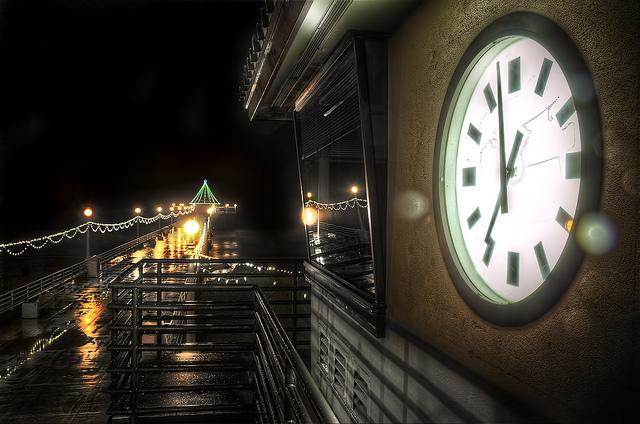Is it late in the day?
Concise answer only. Yes. What time is it?
Keep it brief. 7:00. Does it look like it is raining out?
Quick response, please. Yes. 